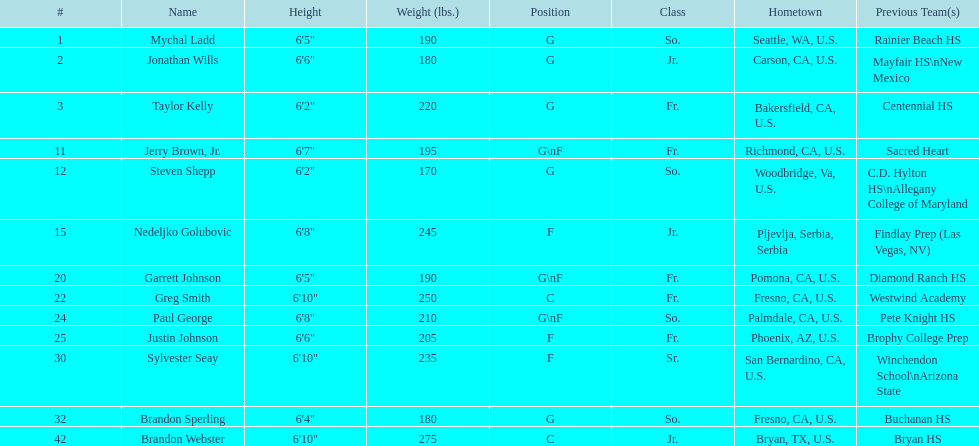Who are all the individuals? Mychal Ladd, Jonathan Wills, Taylor Kelly, Jerry Brown, Jr., Steven Shepp, Nedeljko Golubovic, Garrett Johnson, Greg Smith, Paul George, Justin Johnson, Sylvester Seay, Brandon Sperling, Brandon Webster. What is their stature? 6'5", 6'6", 6'2", 6'7", 6'2", 6'8", 6'5", 6'10", 6'8", 6'6", 6'10", 6'4", 6'10". What about just paul george and greg smith? 6'10", 6'8". And who is the more elevated one between them? Greg Smith. 